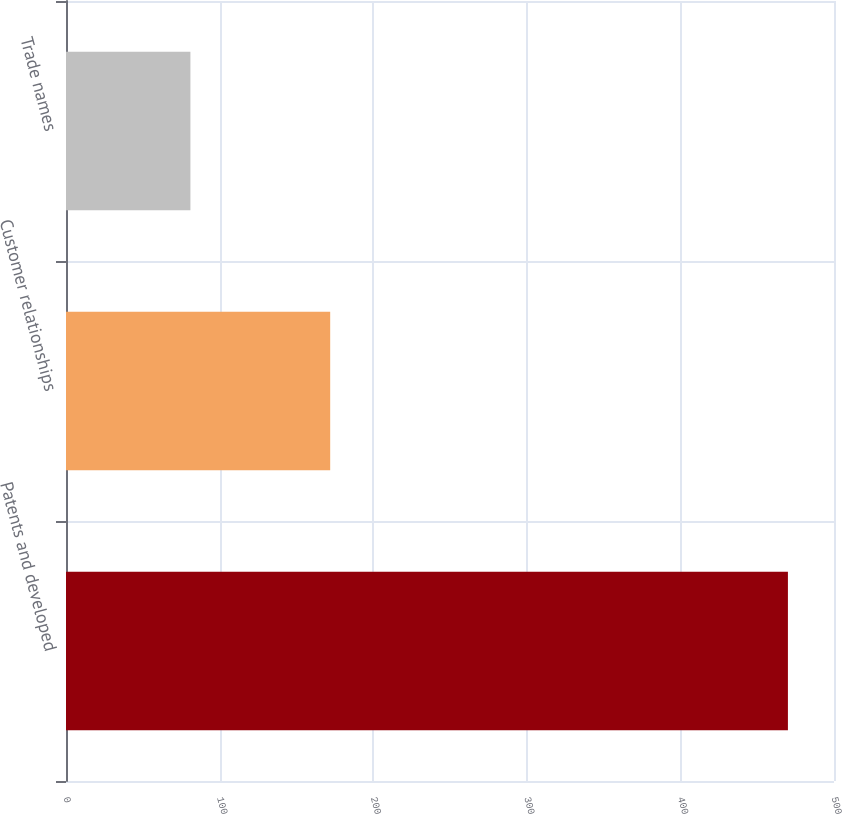Convert chart to OTSL. <chart><loc_0><loc_0><loc_500><loc_500><bar_chart><fcel>Patents and developed<fcel>Customer relationships<fcel>Trade names<nl><fcel>470<fcel>172<fcel>81<nl></chart> 